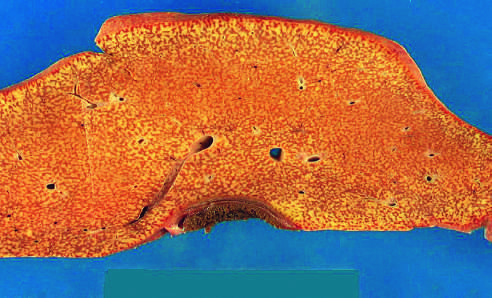s the liver small (700 g), bile-stained, soft, and congested?
Answer the question using a single word or phrase. Yes 